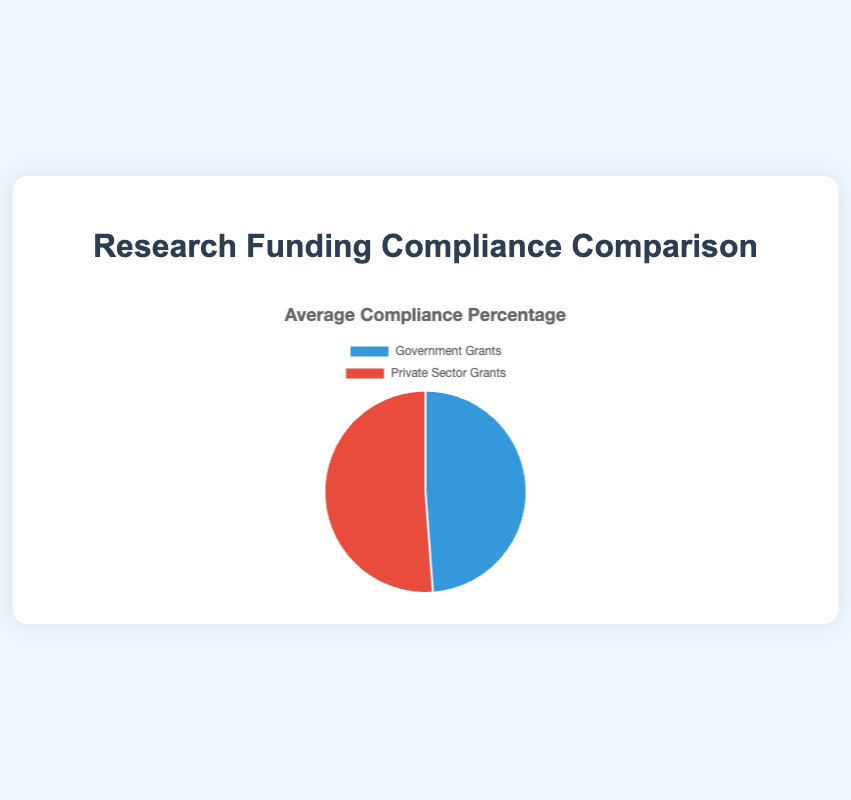What's the average compliance percentage for Government Grants? The average compliance percentage for Government Grants can be calculated by summing the compliance percentages of all the grants in this category and dividing by the number of grants. Adding (92 + 89 + 85 + 87) gives 353. Dividing by 4 gives 88.25%
Answer: 88.25% What's the average compliance percentage for Private Sector Grants? The average compliance percentage for Private Sector Grants can be calculated by summing the compliance percentages of all the grants in this category and dividing by the number of grants. Adding (95 + 93 + 90 + 92) gives 370. Dividing by 4 gives 92.5%
Answer: 92.5% Which category has a higher average compliance percentage? Comparing the average compliance percentages calculated for Government Grants (88.25%) and Private Sector Grants (92.5%), the Private Sector Grants have a higher average compliance percentage.
Answer: Private Sector Grants By how much does the average compliance percentage of Private Sector Grants exceed that of Government Grants? The difference can be calculated by subtracting the average compliance percentage of Government Grants from that of Private Sector Grants. 92.5% - 88.25% = 4.25%
Answer: 4.25% What is the visual color representation for Government Grants in the pie chart? In the pie chart, the Government Grants segment is represented by the color blue.
Answer: Blue What is the visual color representation for Private Sector Grants in the pie chart? In the pie chart, the Private Sector Grants segment is represented by the color red.
Answer: Red If a new grant was added to the Government Grants category with a compliance percentage of 80%, how would the average compliance percentage of Government Grants change? With a new grant at 80%, sum the updated percentages: 92 + 89 + 85 + 87 + 80 = 433. Then, divide by the number of grants, 433 / 5 = 86.6%
Answer: 86.6% What is the highest compliance percentage among Government Grants, and to which grant does it belong? The highest compliance percentage among Government Grants is 92%, which belongs to the National Science Foundation.
Answer: National Science Foundation Compare the highest compliance percentage in Private Sector Grants to the highest in Government Grants. Which is higher and by how much? The highest compliance percentage in Private Sector Grants is 95% (Bill & Melinda Gates Foundation), and the highest in Government Grants is 92% (National Science Foundation). By comparing, 95% - 92% = 3%, so Private Sector Grants is higher by 3%.
Answer: Private Sector Grants by 3% If both a Government and a Private Sector grant with compliance percentages of 89% and 91% respectively were removed from their categories, how would this affect the average compliance percentages of each category? **For Government Grants:** Removing 89%, the new sum is (92 + 85 + 87) = 264. Average becomes 264 / 3 = 88%.  
**For Private Sector Grants:** Removing 91%, the new sum is (95 + 93 + 90) = 278. Average becomes 278 / 3 = 92.67%.
Answer: Government Grants: 88%, Private Sector Grants: 92.67% 